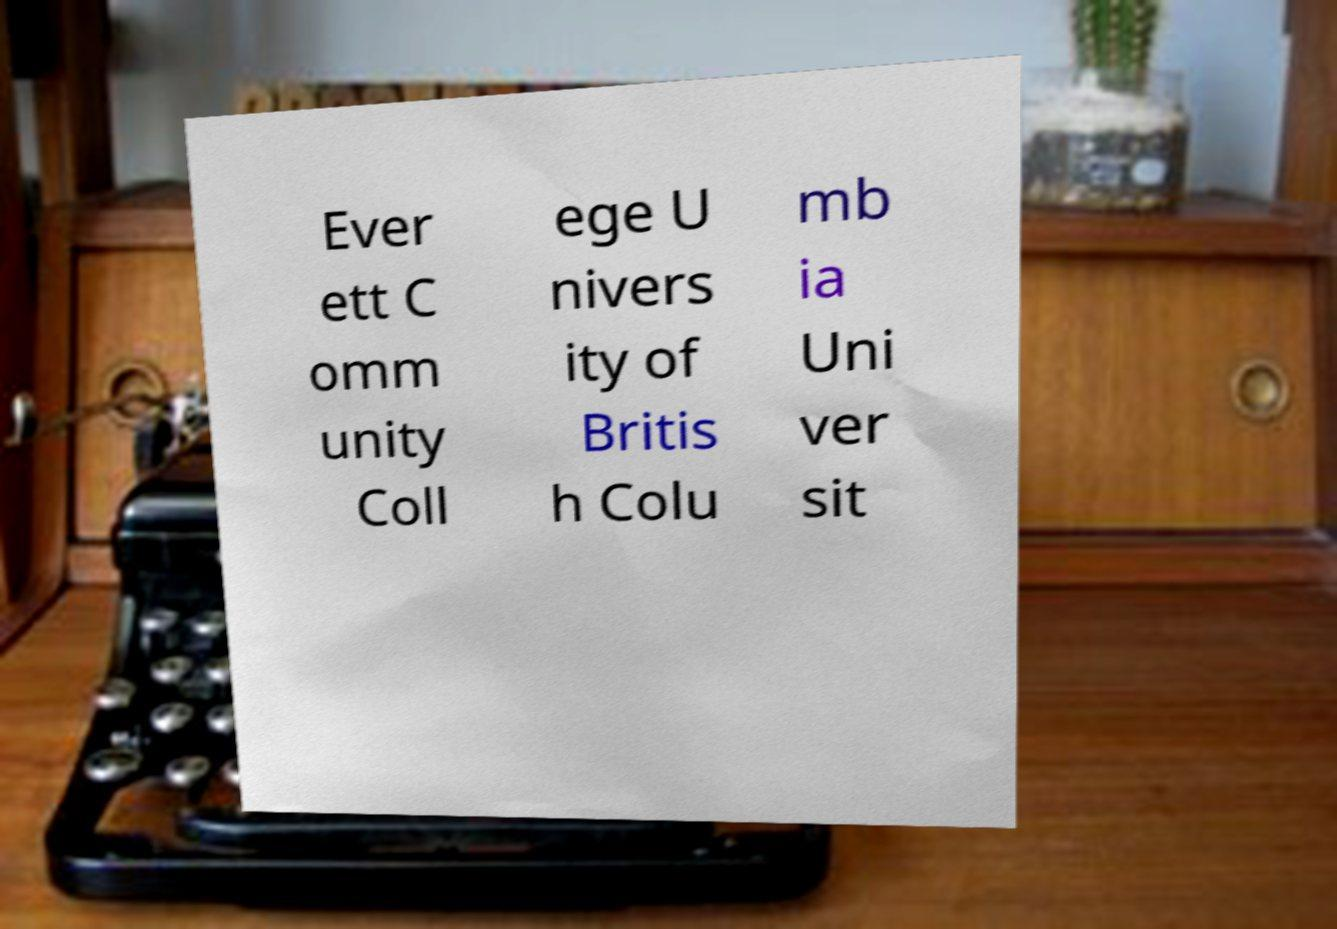Can you read and provide the text displayed in the image?This photo seems to have some interesting text. Can you extract and type it out for me? Ever ett C omm unity Coll ege U nivers ity of Britis h Colu mb ia Uni ver sit 